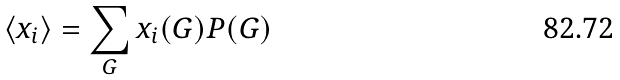Convert formula to latex. <formula><loc_0><loc_0><loc_500><loc_500>\langle x _ { i } \rangle = \sum _ { G } x _ { i } ( G ) P ( G )</formula> 